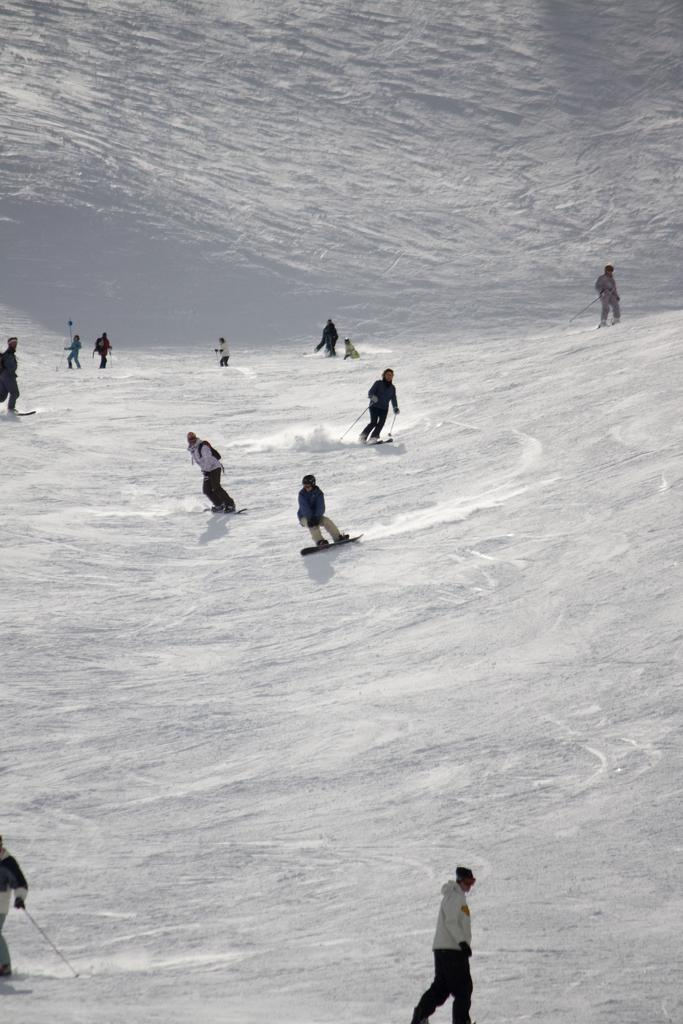What is the condition of the land in the image? The land is covered with snow. What are the people in the image doing? The people are standing on snowboards. Can you describe the activity the people are engaged in? The people are likely snowboarding, given that they are standing on snowboards and the land is covered with snow. What type of brake can be seen on the snowboard in the image? There is no brake visible on the snowboard in the image. How many stars are visible in the sky in the image? The image does not show the sky, so it is impossible to determine how many stars are visible. 